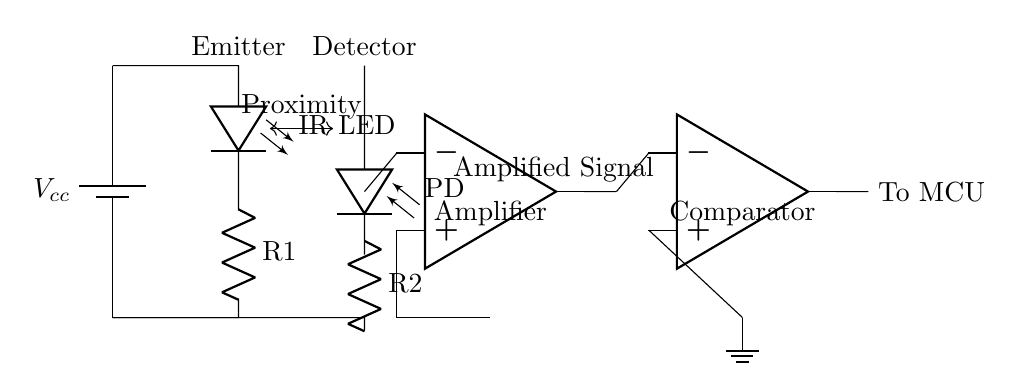What is the function of the IR LED in this circuit? The IR LED acts as an emitter, sending out infrared light to detect proximity when an object obstructs the emitted light.
Answer: Emitter What component amplifies the signal in the circuit? The operational amplifier (op amp) is used to amplify the signal received from the photodiode, allowing for better detection of proximity changes.
Answer: Amplifier How many resistors are in the circuit? There are two resistors present in the circuit, labeled R1 and R2, which are used to limit current in different parts of the circuit.
Answer: Two What does the photodiode detect? The photodiode detects the infrared light emitted by the IR LED, which changes depending on the proximity of an object in front of it.
Answer: Infrared light What is the output of the comparator connected to? The output of the comparator is connected to a microcontroller unit (MCU), which processes the signal to determine whether to dim the screen based on proximity.
Answer: MCU What happens when an object is close to the IR LED? When an object is close, the photodiode receives more reflected infrared light, changing the output of the operational amplifier and, consequently, the comparator.
Answer: Signal change 